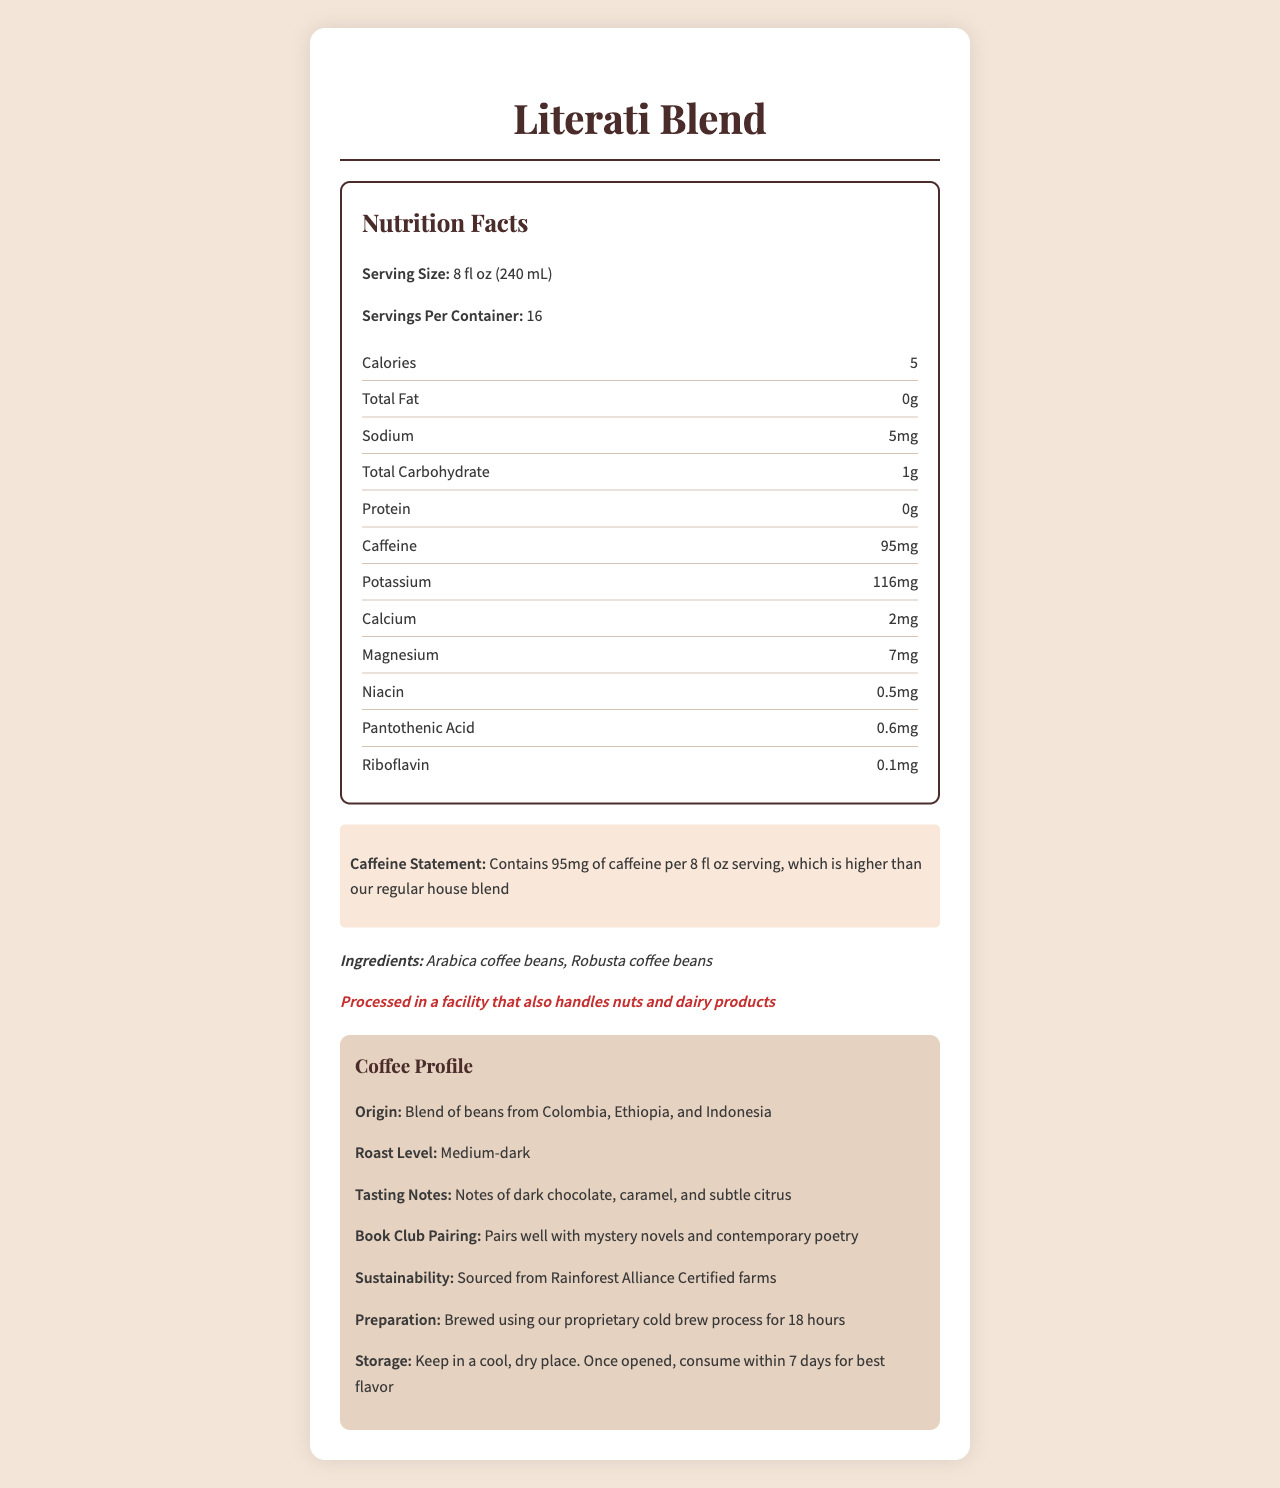what is the serving size for the Literati Blend? The serving size is explicitly mentioned in the Nutrition Facts section of the document.
Answer: 8 fl oz (240 mL) how many servings are there per container? The document states that there are 16 servings per container.
Answer: 16 what is the caffeine content per serving? The caffeine content per serving is stated in both the Nutrition Facts and highlighted sections as 95mg per 8 fl oz serving.
Answer: 95mg what are the main ingredients of the Literati Blend? The ingredients are explicitly listed in the ingredients section of the document.
Answer: Arabica coffee beans, Robusta coffee beans what book genres does this coffee blend pair well with? The book club pairing note mentions that the Literati Blend pairs well with mystery novels and contemporary poetry.
Answer: Mystery novels and contemporary poetry which nutrient has the highest quantity in the Literati Blend? A. Sodium B. Calcium C. Potassium D. Magnesium Given the quantities of nutrients listed, potassium has the highest quantity at 116mg per serving.
Answer: C. Potassium how many calories are in a single serving of Literati Blend? The Nutrition Facts section states that there are 5 calories per serving.
Answer: 5 Is the Literati Blend sourced from Rainforest Alliance Certified farms? The document specifies in the sustainability info section that the coffee beans are sourced from Rainforest Alliance Certified farms.
Answer: Yes what is the roast level of this coffee blend? The roast level section specifies that the Literati Blend is a medium-dark roast.
Answer: Medium-dark how long should you consume the coffee after opening for best flavor? The storage instructions advise consuming the coffee within 7 days for the best flavor.
Answer: Within 7 days which of the following is NOT part of the tasting notes for Literati Blend? A. Dark Chocolate B. Caramel C. Vanilla D. Citrus The tasting notes mention "dark chocolate," "caramel," and "subtle citrus," but do not mention "vanilla".
Answer: C. Vanilla is this coffee blend suitable for individuals with nut allergies? The allergen info states that the product is processed in a facility that also handles nuts, indicating a potential for cross-contamination.
Answer: No summarize the main idea of the document. The explanation emphasizes the purpose of the document, which is to inform consumers about the nutritional content, sustainability, preparation, and taste profile of the Literati Blend coffee.
Answer: The document provides detailed Nutrition Facts and other pertinent information for the Literati Blend specialty coffee. It highlights the serving size, nutritional content, high caffeine content, ingredients, allergen information, sustainability practices, tasting notes, and suggested book pairings. It is designed to present all essential information for consumers interested in the coffee's health and taste profile. what is the total carbohydrate content in a serving of Literati Blend? The total carbohydrate content per serving is listed as 1g in the Nutrition Facts.
Answer: 1g how often should the Literati Blend be brewed for best flavor? The document does not provide specific frequency recommendations for brewing to maintain the best flavor.
Answer: Not enough information 